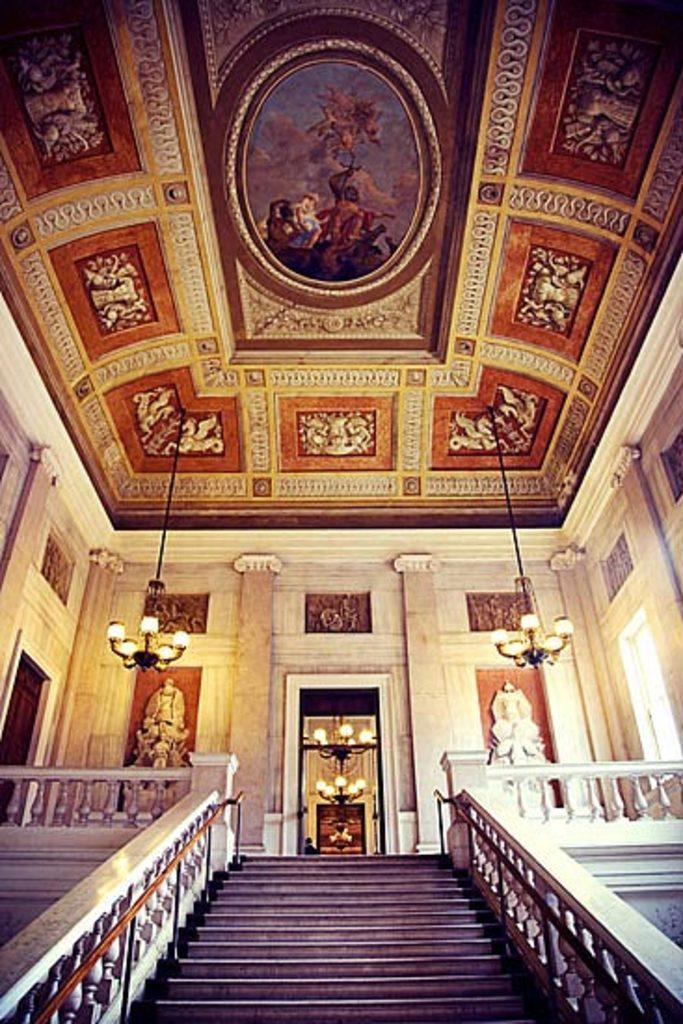What type of location is depicted in the image? The image is an inner view of a building. What architectural feature can be seen in the image? There is a staircase in the image. What decorative elements are present in the image? There are statues in the image. What structural element is visible in the image? There is a wall in the image. What functional elements can be seen in the image? There are doors in the image. What is on the roof in the image? The roof has pictures in the image. What lighting feature is present in the image? There are ceiling lights in the image. Can you see a cherry tree in the image? There is no cherry tree present in the image; it is an indoor view of a building. Is this a bedroom in the image? The image does not depict a bedroom; it is an inner view of a building with a staircase, statues, wall, doors, roof pictures, and ceiling lights. 